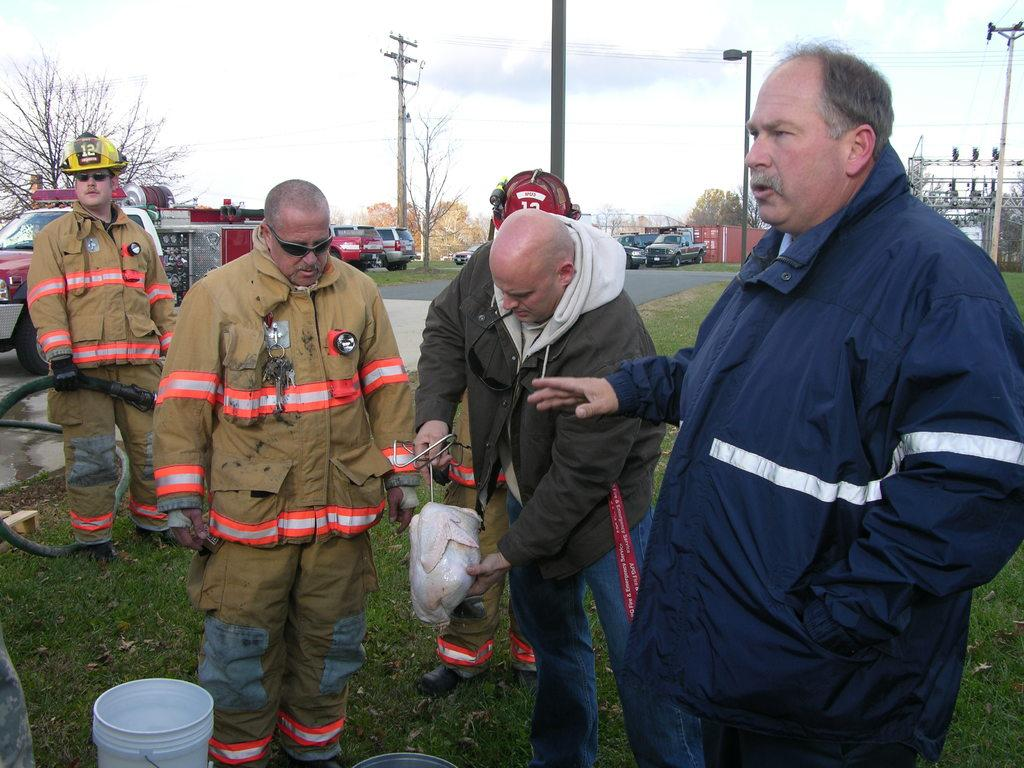Who or what can be seen in the image? There are people in the image. What type of terrain is visible in the image? There is grass in the image. What object is present for carrying or holding items? There is a bucket in the image. What type of transportation is visible in the image? There are vehicles in the image. What type of vegetation is visible in the image? There are trees in the image. What type of utility pole is visible in the image? There is a current pole in the image. What type of lighting fixture is visible in the image? There is a street lamp in the image. What part of the natural environment is visible in the image? The sky is visible in the image. Can you tell me which actor is playing the lead role in the image? There is no actor or lead role present in the image; it features people, grass, a bucket, vehicles, trees, a current pole, a street lamp, and the sky. How many marks are visible on the current pole in the image? There are no marks visible on the current pole in the image; it is a single pole. 